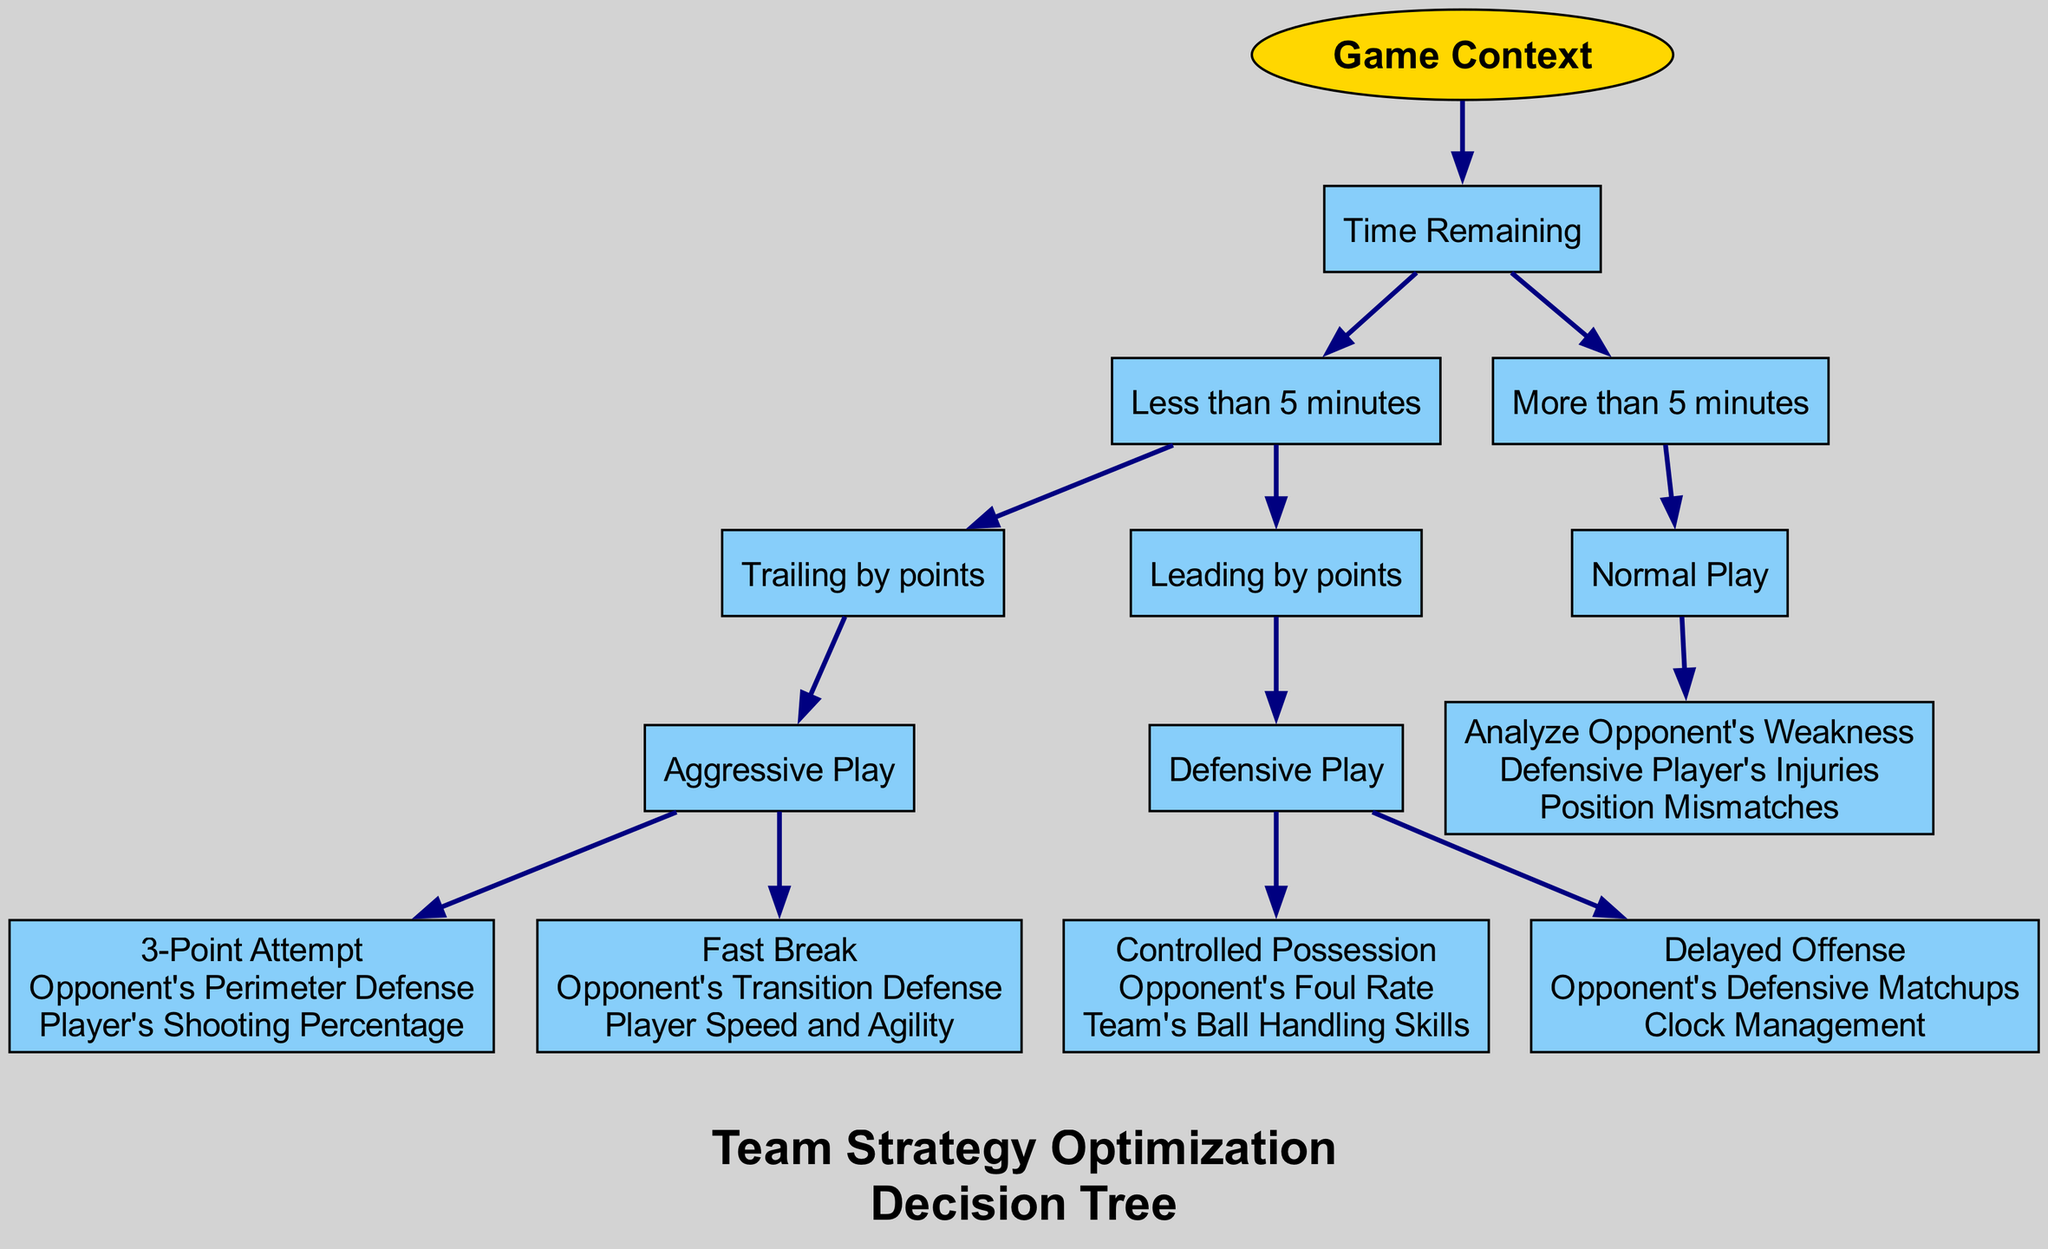What is the root of the decision tree? The root node of the decision tree is "Game Context," which is the starting point for all strategic decisions outlined in the diagram.
Answer: Game Context How many primary branches are there under "Time Remaining"? Under the "Time Remaining" node, there are two primary branches: "Less than 5 minutes" and "More than 5 minutes."
Answer: Two What option is chosen when trailing by points in less than 5 minutes? The option chosen when trailing by points in less than 5 minutes is "Aggressive Play." This node specifically dictates the strategy during critical late-game situations when behind in score.
Answer: Aggressive Play What is the consideration for "Delayed Offense"? The considerations for "Delayed Offense" include "Opponent's Defensive Matchups" and "Clock Management," highlighting strategies for controlling the pace of the game while leading.
Answer: Opponent's Defensive Matchups, Clock Management How does the diagram suggest to handle a situation when leading by points with less than 5 minutes left? When leading by points in less than 5 minutes left, the diagram suggests using "Defensive Play." This includes controlling the game to maintain the lead rather than aggressively pursuing additional points.
Answer: Defensive Play If the opponent has defensive player injuries, which node should be analyzed? If the opponent has defensive player injuries, the diagram suggests analyzing "Opponent's Weakness," as it directly relates to exploiting vulnerabilities in the opposing team's defense.
Answer: Analyze Opponent's Weakness What type of play is suggested for normal play when there is more than 5 minutes left? The suggested type of play during normal play with more than 5 minutes remaining is "Analyze Opponent's Weakness." This emphasizes strategic planning for longer-term adjustments.
Answer: Analyze Opponent's Weakness What consideration is included when making a "3-Point Attempt"? The considerations for making a "3-Point Attempt" include "Opponent's Perimeter Defense" and "Player's Shooting Percentage," indicating the need to evaluate external conditions and player capabilities before the attempt.
Answer: Opponent's Perimeter Defense, Player's Shooting Percentage 